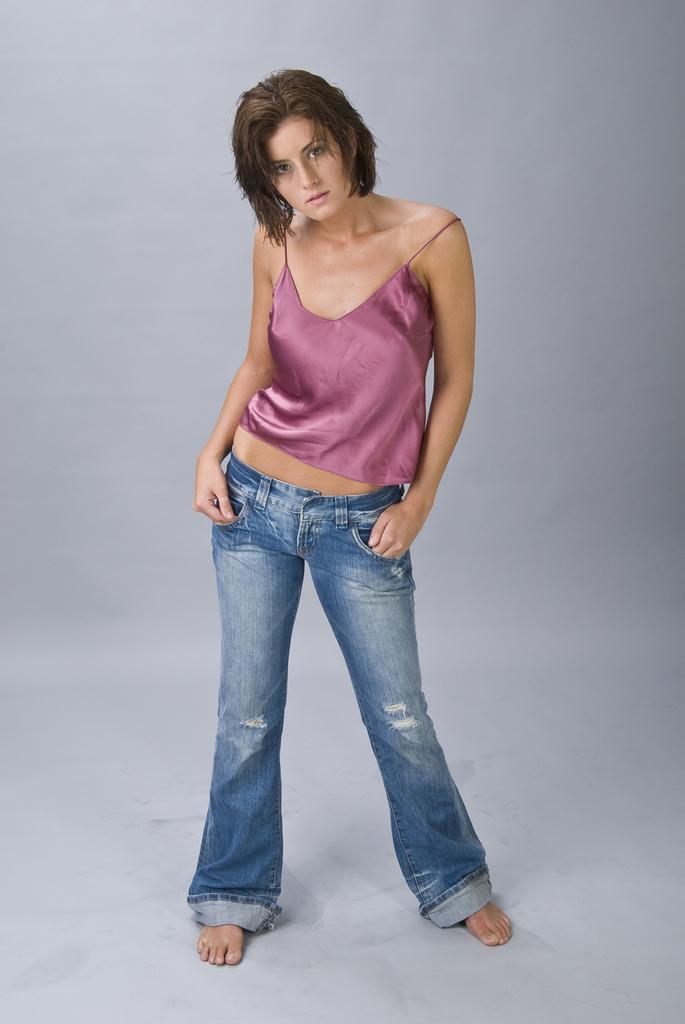Can you describe this image briefly? In this image we can see a woman is standing on the white color surface. She is wearing a pink top and jeans. 